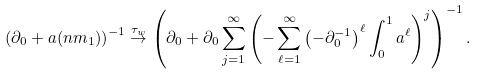<formula> <loc_0><loc_0><loc_500><loc_500>\left ( \partial _ { 0 } + a ( n m _ { 1 } ) \right ) ^ { - 1 } \stackrel { \tau _ { w } } { \to } \left ( \partial _ { 0 } + \partial _ { 0 } \sum _ { j = 1 } ^ { \infty } \left ( - \sum _ { \ell = 1 } ^ { \infty } \left ( - \partial _ { 0 } ^ { - 1 } \right ) ^ { \ell } \int _ { 0 } ^ { 1 } a ^ { \ell } \right ) ^ { j } \right ) ^ { - 1 } .</formula> 